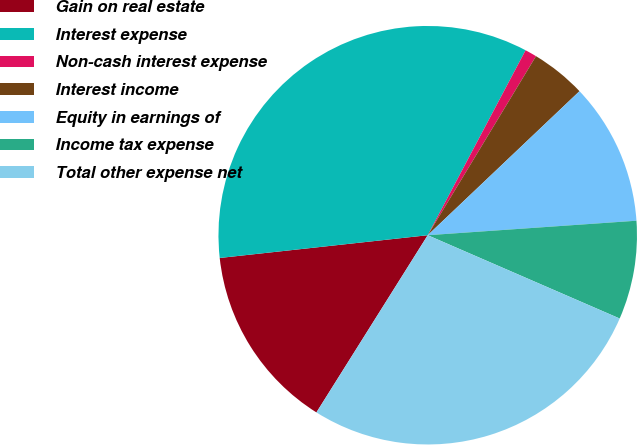Convert chart. <chart><loc_0><loc_0><loc_500><loc_500><pie_chart><fcel>Gain on real estate<fcel>Interest expense<fcel>Non-cash interest expense<fcel>Interest income<fcel>Equity in earnings of<fcel>Income tax expense<fcel>Total other expense net<nl><fcel>14.34%<fcel>34.48%<fcel>0.91%<fcel>4.26%<fcel>10.98%<fcel>7.62%<fcel>27.41%<nl></chart> 